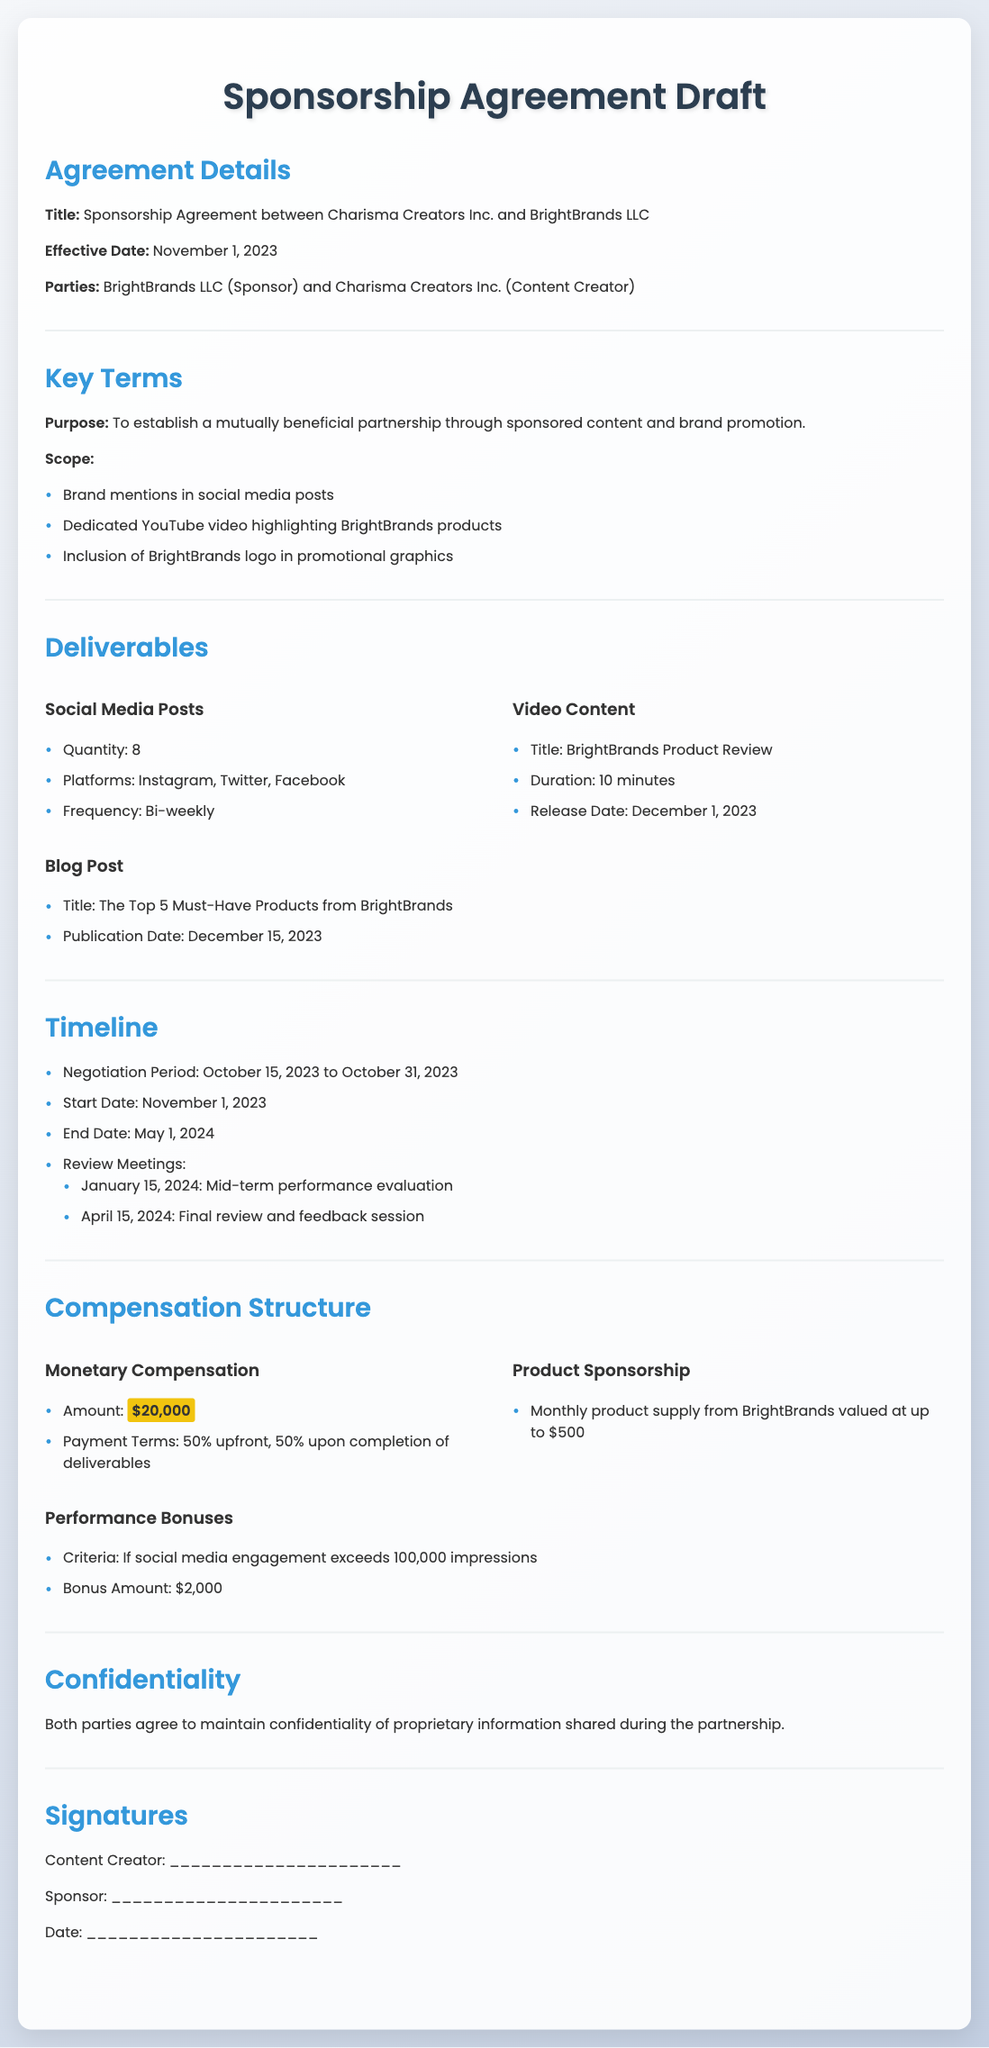what is the title of the agreement? The title of the agreement is stated in the first section and is "Sponsorship Agreement between Charisma Creators Inc. and BrightBrands LLC".
Answer: Sponsorship Agreement between Charisma Creators Inc. and BrightBrands LLC what is the effective date of the sponsorship agreement? The effective date is mentioned in the Agreement Details section.
Answer: November 1, 2023 how many social media posts are required? The number of social media posts is specified in the Deliverables section under Social Media Posts.
Answer: 8 what is the total monetary compensation? The total monetary compensation is detailed in the Compensation Structure section.
Answer: $20,000 when is the mid-term performance evaluation scheduled? The date for the mid-term evaluation is listed under the Timeline section.
Answer: January 15, 2024 what is included in the product sponsorship? The details about product sponsorship can be found in the Compensation Structure section.
Answer: Monthly product supply from BrightBrands valued at up to $500 how often will social media posts be published? The frequency of social media posts is provided in the Deliverables section.
Answer: Bi-weekly what are the performance bonus criteria? The criteria for the performance bonus are mentioned in the Compensation Structure section.
Answer: If social media engagement exceeds 100,000 impressions what is the final review date? The final review date is specified in the Timeline section.
Answer: April 15, 2024 